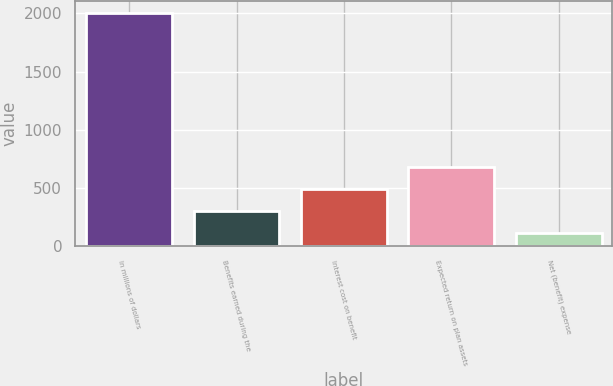Convert chart. <chart><loc_0><loc_0><loc_500><loc_500><bar_chart><fcel>In millions of dollars<fcel>Benefits earned during the<fcel>Interest cost on benefit<fcel>Expected return on plan assets<fcel>Net (benefit) expense<nl><fcel>2006<fcel>304.1<fcel>493.2<fcel>682.3<fcel>115<nl></chart> 